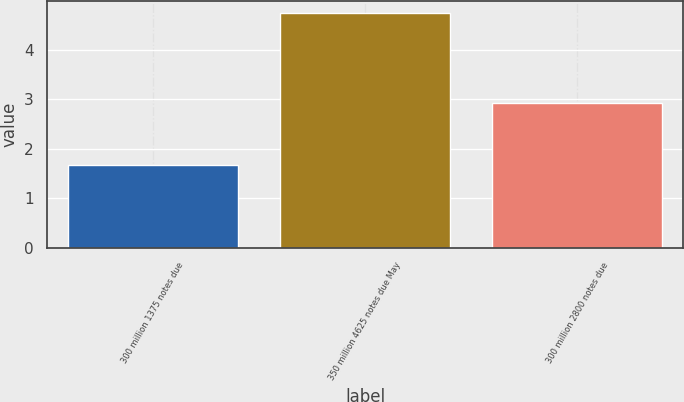<chart> <loc_0><loc_0><loc_500><loc_500><bar_chart><fcel>300 million 1375 notes due<fcel>350 million 4625 notes due May<fcel>300 million 2800 notes due<nl><fcel>1.66<fcel>4.74<fcel>2.93<nl></chart> 